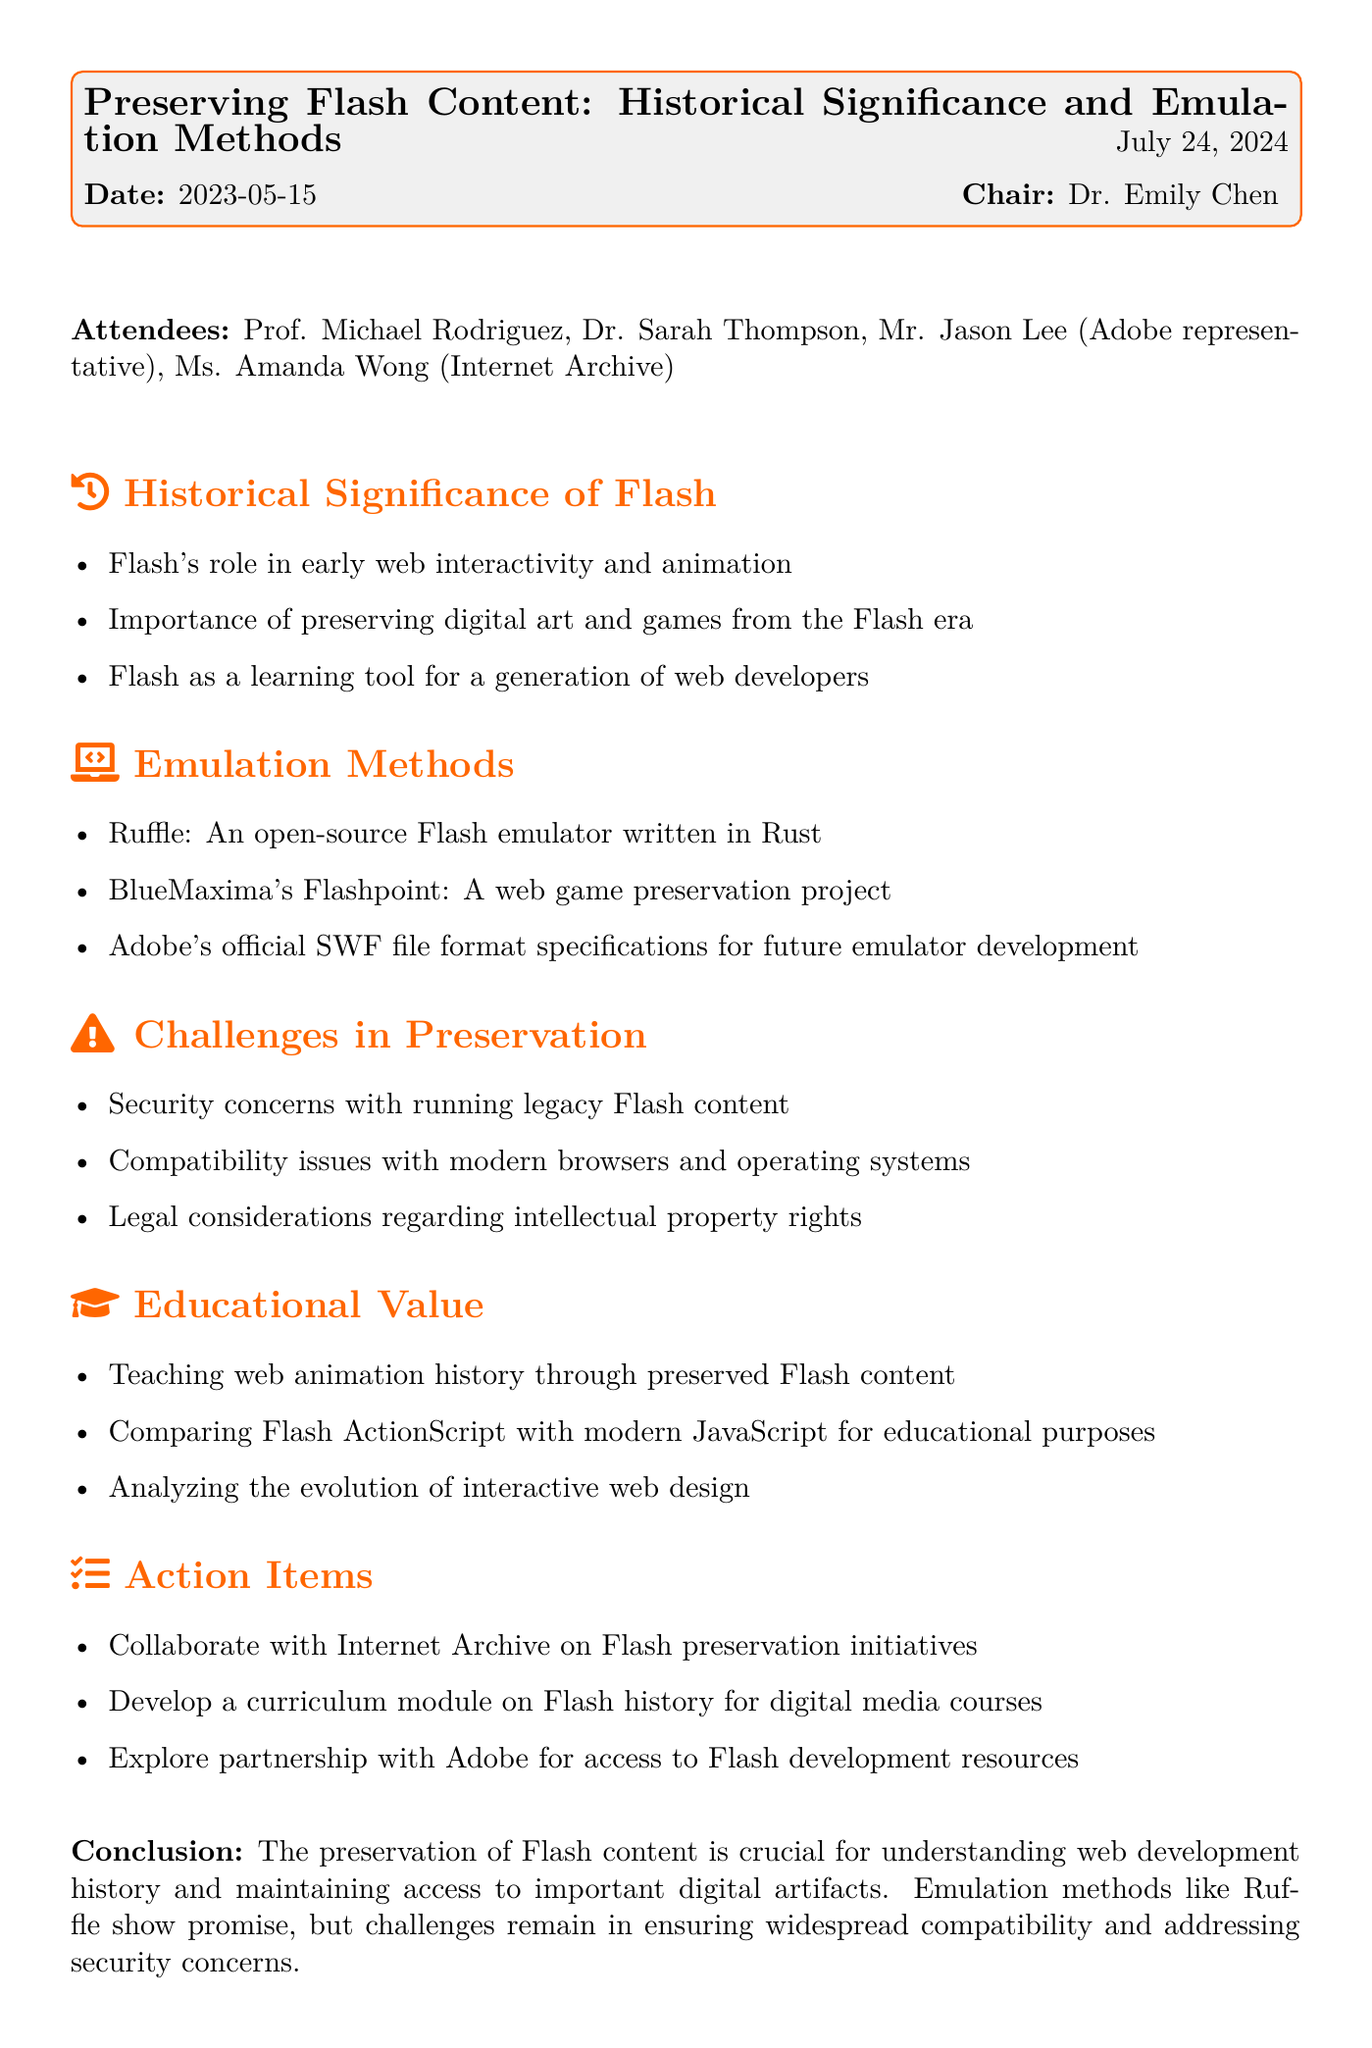What is the meeting title? The meeting title is mentioned at the top of the document.
Answer: Preserving Flash Content: Historical Significance and Emulation Methods Who chaired the meeting? The name of the chair is listed in the meeting information section.
Answer: Dr. Emily Chen What date was the meeting held? The date of the meeting is provided at the beginning.
Answer: 2023-05-15 Which emulation method is an open-source Flash emulator written in Rust? This is specified under the Emulation Methods section.
Answer: Ruffle What are two challenges mentioned in the document regarding Flash preservation? The challenges listed in the Challenges in Preservation section include several items.
Answer: Security concerns and compatibility issues What educational value is mentioned in relation to Flash content? The document lists several educational benefits in the Educational Value section.
Answer: Teaching web animation history How many action items were listed in the meeting? The number of action items can be counted from the Action Items section.
Answer: Three Who represented Adobe at the meeting? The name of the Adobe representative is listed in the attendees.
Answer: Mr. Jason Lee What is one task noted for collaboration in the Action Items? One of the tasks outlines collaboration noted in the Action Items section.
Answer: Collaborate with Internet Archive on Flash preservation initiatives 